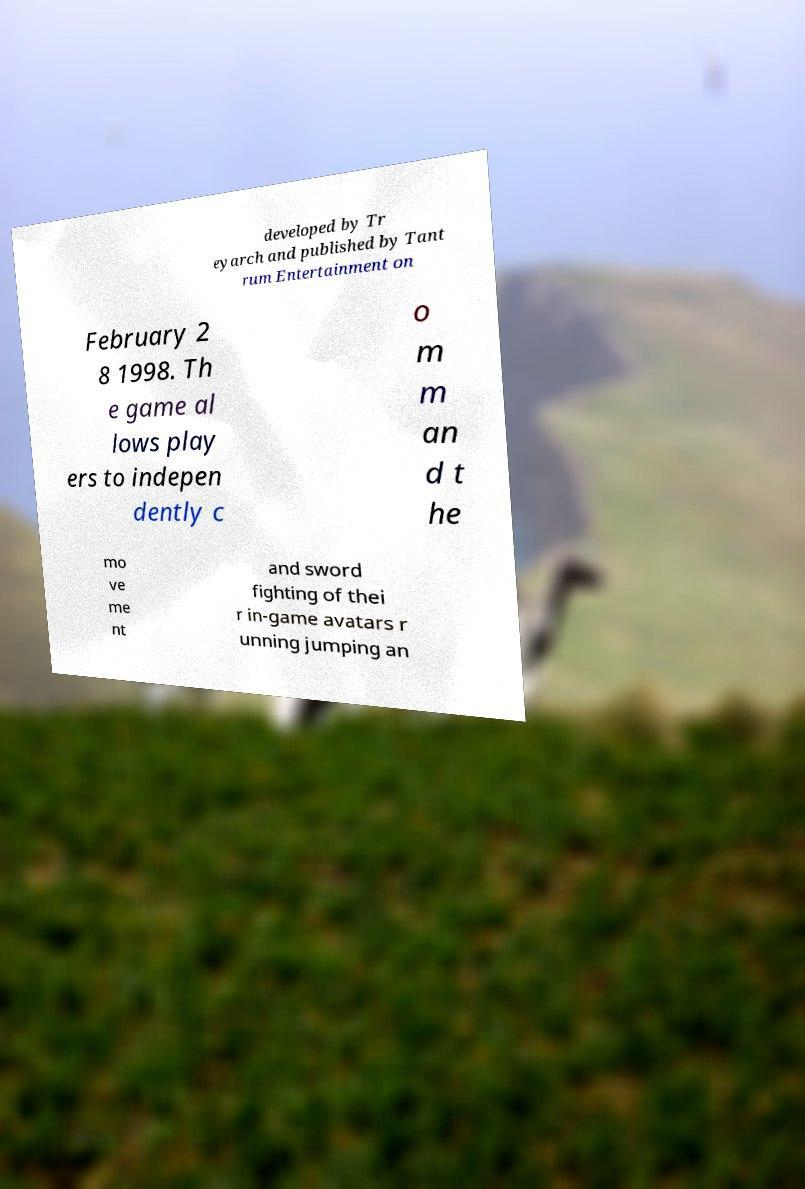Could you assist in decoding the text presented in this image and type it out clearly? developed by Tr eyarch and published by Tant rum Entertainment on February 2 8 1998. Th e game al lows play ers to indepen dently c o m m an d t he mo ve me nt and sword fighting of thei r in-game avatars r unning jumping an 